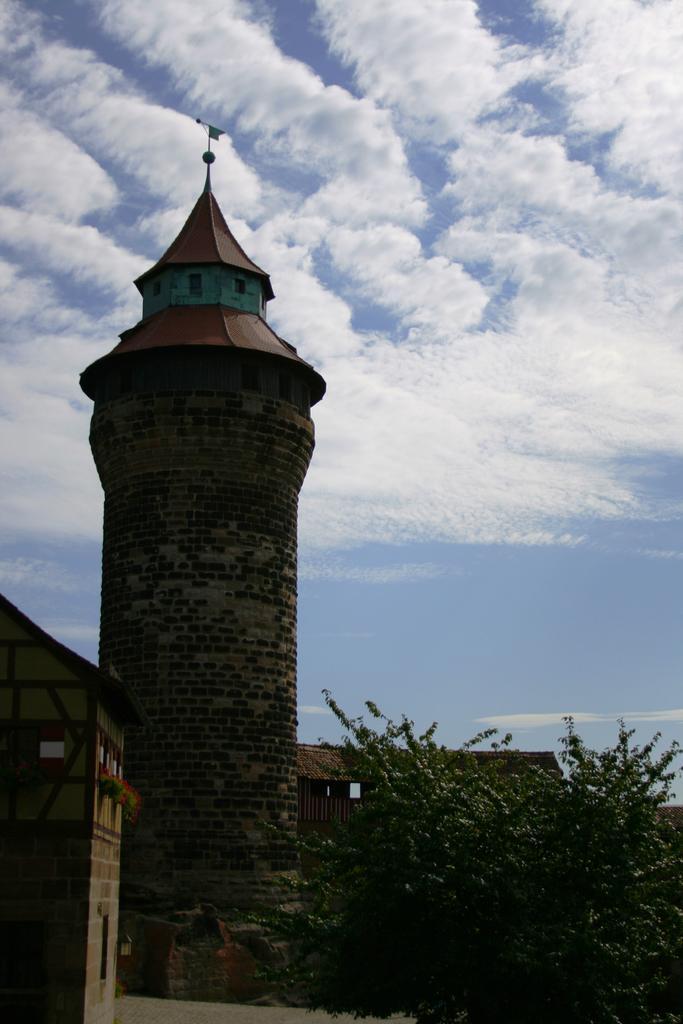In one or two sentences, can you explain what this image depicts? In this picture we can see a tree in the front, on the left side there is a building, we can see a tower in the middle, there is the sky at the top of the picture. 